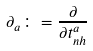<formula> <loc_0><loc_0><loc_500><loc_500>\partial _ { a } \colon = \frac { \partial } { \partial t ^ { a } _ { n h } } \,</formula> 